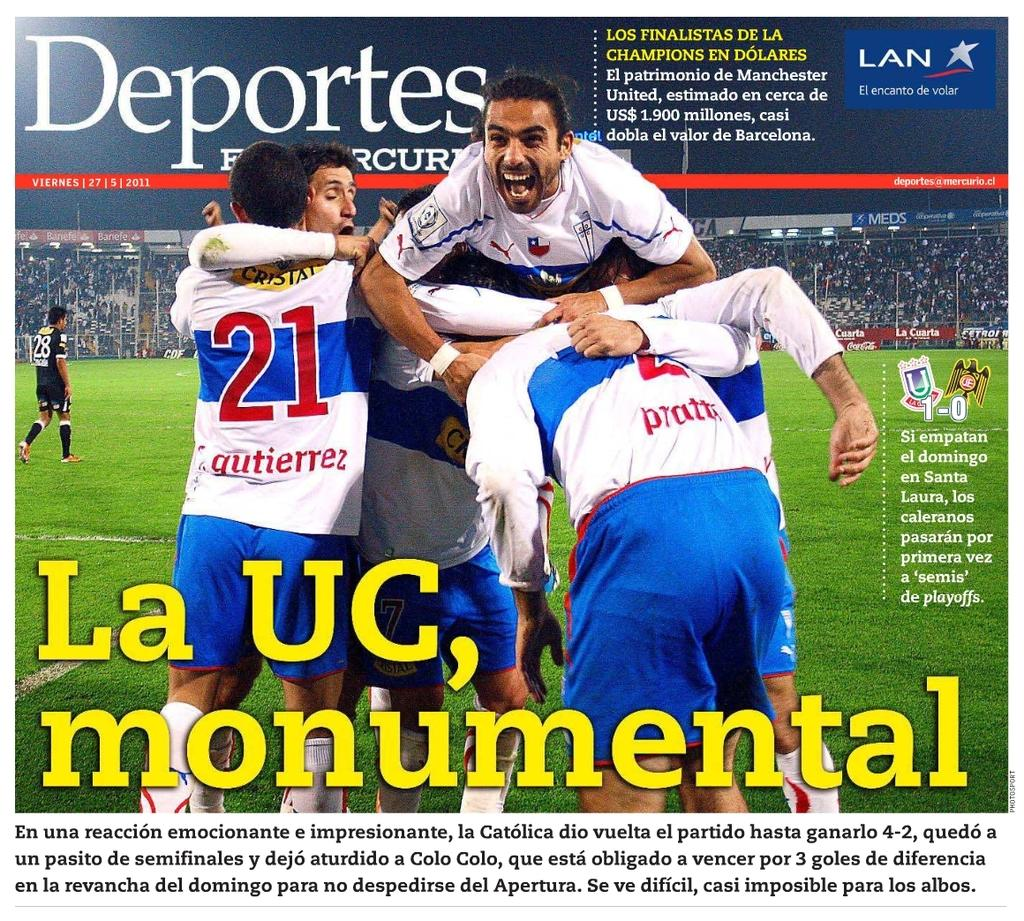<image>
Render a clear and concise summary of the photo. Deportes magazine shows men celebrating a win on the cover. 